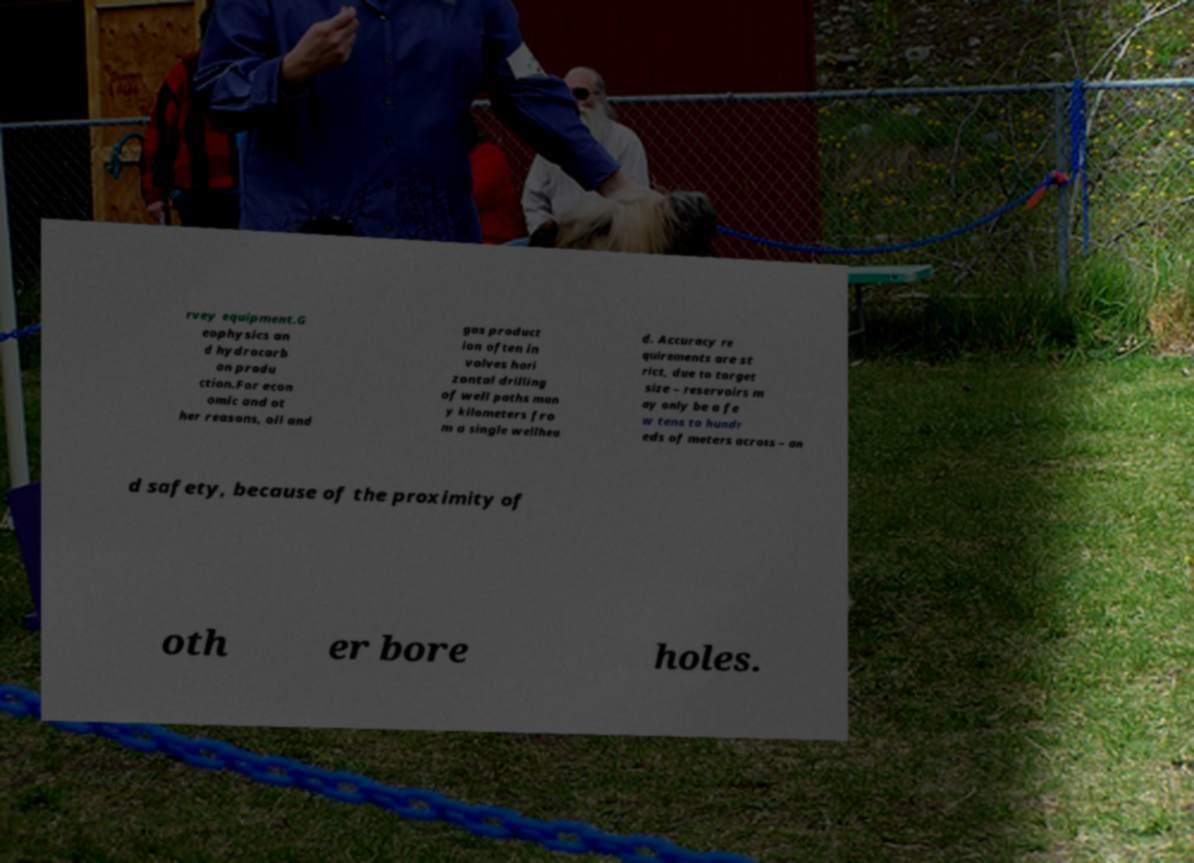What messages or text are displayed in this image? I need them in a readable, typed format. rvey equipment.G eophysics an d hydrocarb on produ ction.For econ omic and ot her reasons, oil and gas product ion often in volves hori zontal drilling of well paths man y kilometers fro m a single wellhea d. Accuracy re quirements are st rict, due to target size – reservoirs m ay only be a fe w tens to hundr eds of meters across – an d safety, because of the proximity of oth er bore holes. 